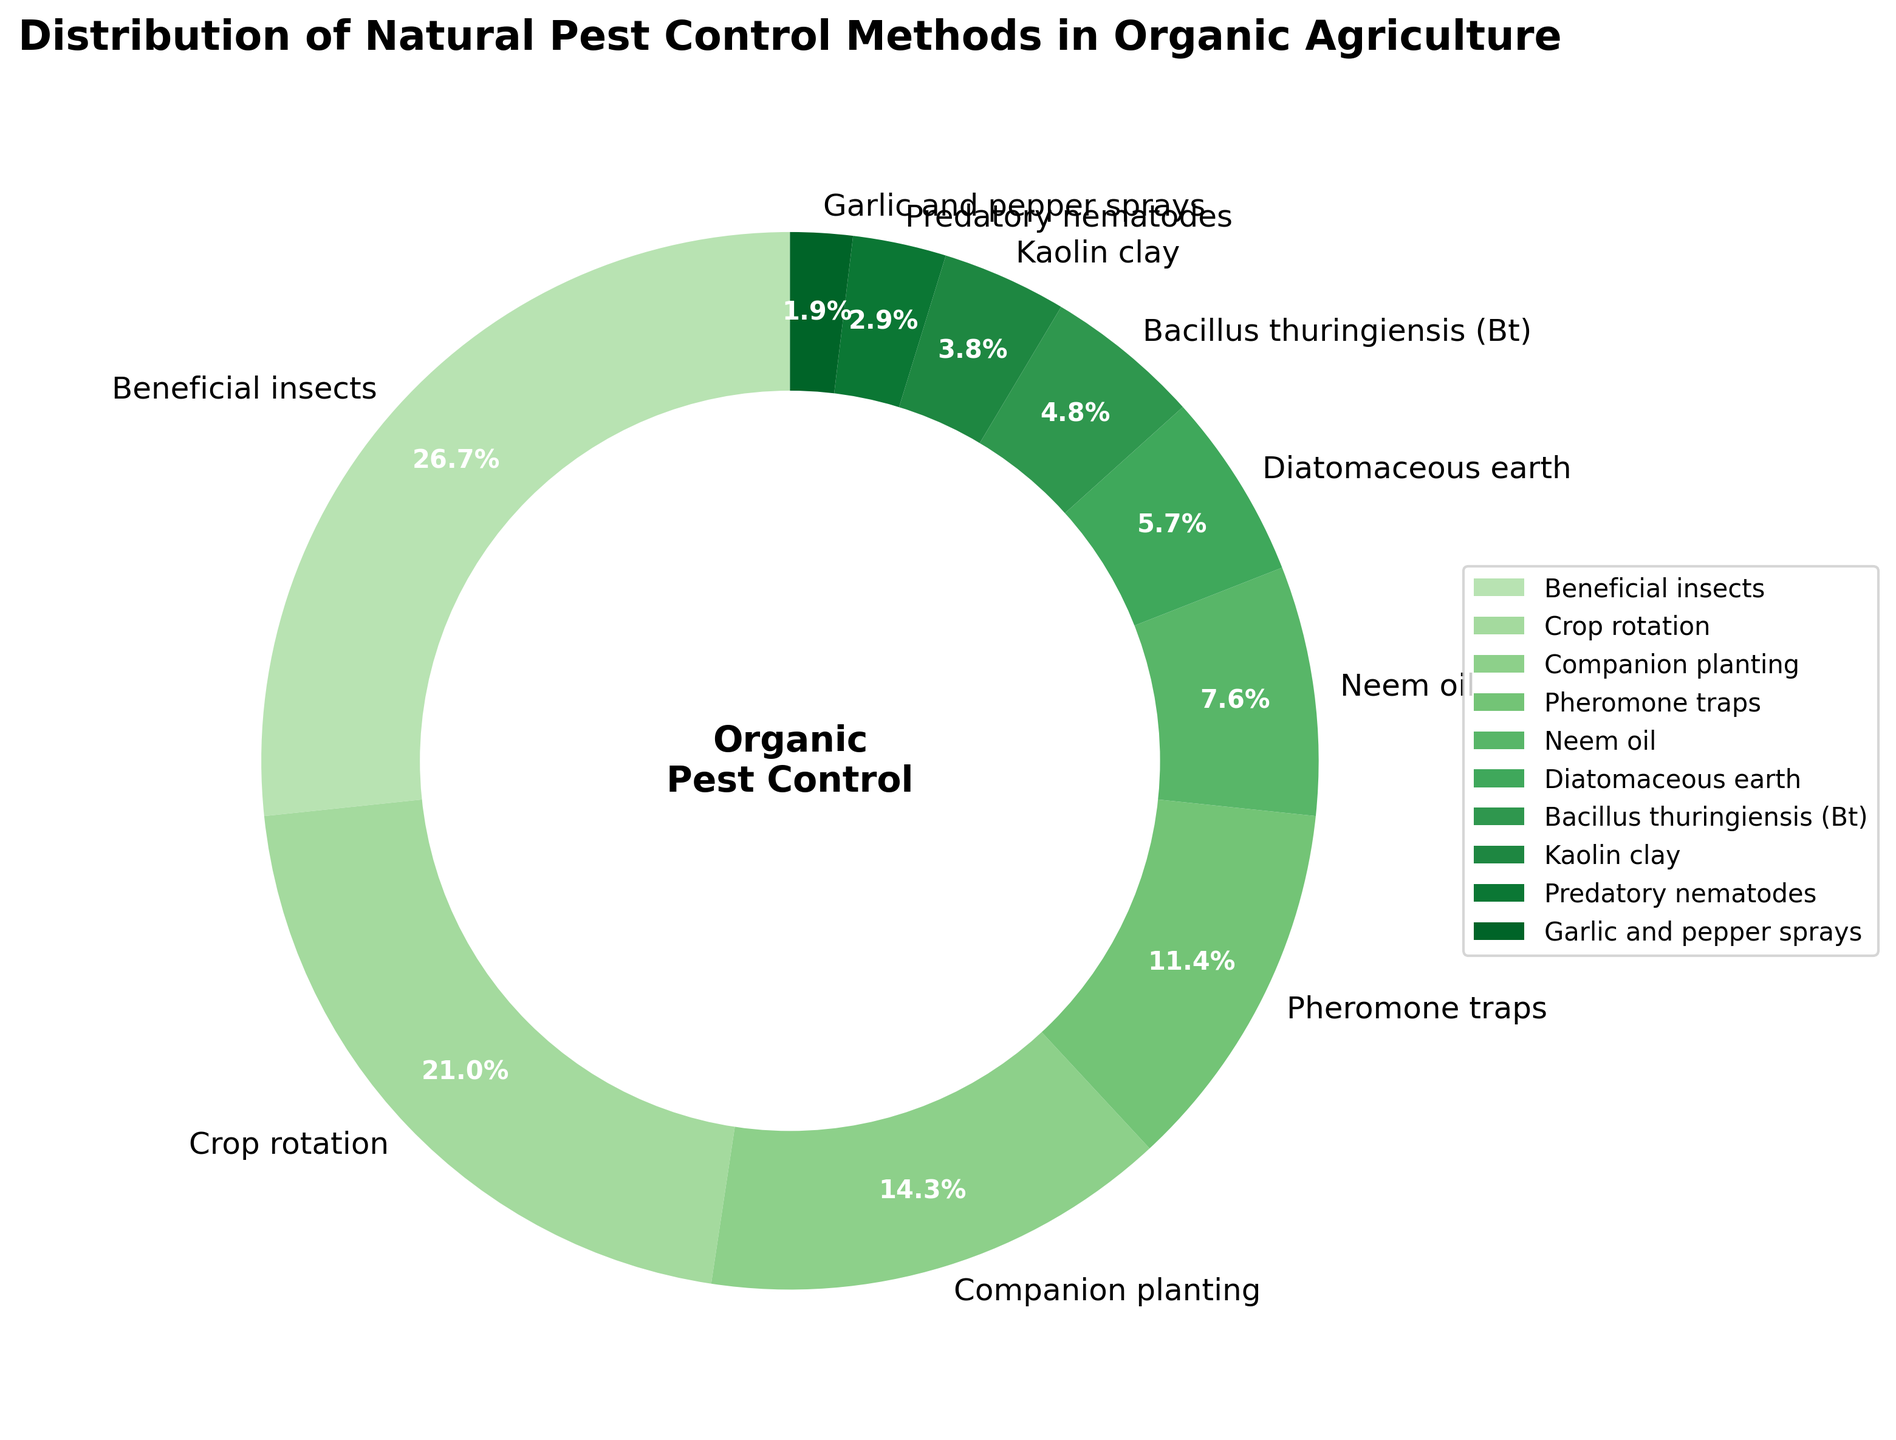Which method has the highest usage percentage? By checking the pie chart, we can see the largest segment is labeled "Beneficial insects" with a percentage of 28%.
Answer: Beneficial insects How much higher is the percentage of "Beneficial insects" compared to "Crop rotation"? The percentage for "Beneficial insects" is 28%, and for "Crop rotation" it is 22%. Subtracting these gives 28% - 22% = 6%.
Answer: 6% What is the combined percentage of "Diatomaceous earth" and "Garlic and pepper sprays"? The percentage for "Diatomaceous earth" is 6% and for "Garlic and pepper sprays" it is 2%. Adding these together gives 6% + 2% = 8%.
Answer: 8% Which methods combined make up less than 10% of the pie chart? The methods "Bacillus thuringiensis (Bt)", "Kaolin clay", "Predatory nematodes", and "Garlic and pepper sprays" have percentages of 5%, 4%, 3%, and 2% respectively. Adding these gives 5% + 4% + 3% + 2% = 14%, so methods need to be <5% individually, only "Predatory nematodes" and "Garlic and pepper sprays" fit.
Answer: Predatory nematodes and Garlic and pepper sprays How does the percentage of "Companion planting" compare to "Pheromone traps"? "Companion planting" has a percentage of 15%, while "Pheromone traps" has 12%. "Companion planting" is higher by 3%.
Answer: Companion planting What percentage of the pie chart is accounted for by the three least used methods combined? The least used methods are "Garlic and pepper sprays" (2%), "Predatory nematodes" (3%), and "Kaolin clay" (4%). Adding these, 2% + 3% + 4% = 9%.
Answer: 9% What are the two most prevalent methods and their combined percentage? The two methods with the highest percentages are "Beneficial insects" (28%) and "Crop rotation" (22%). Their combined percentage is 28% + 22% = 50%.
Answer: Beneficial insects and Crop rotation, 50% Out of "Neem oil" and "Diatomaceous earth," which has a higher percentage, and by how much? "Neem oil" has a percentage of 8%, and "Diatomaceous earth" has 6%. "Neem oil" is higher by 2%.
Answer: Neem oil, 2% What fraction of the pie chart is made up by "Crop rotation" and "Pheromone traps"? "Crop rotation" takes up 22% and "Pheromone traps" 12%. Adding these together, 22% + 12% = 34%, which is equivalent to 34/100 or 0.34 of the pie chart.
Answer: 0.34 